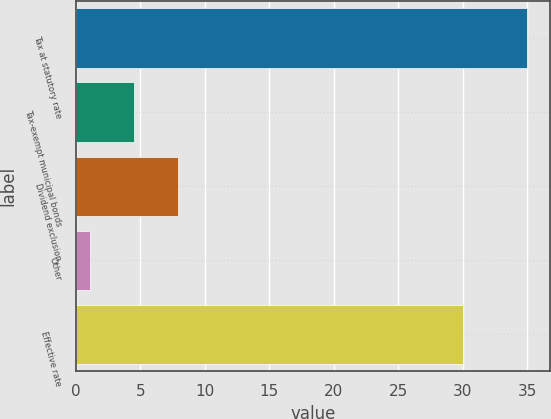Convert chart. <chart><loc_0><loc_0><loc_500><loc_500><bar_chart><fcel>Tax at statutory rate<fcel>Tax-exempt municipal bonds<fcel>Dividend exclusion<fcel>Other<fcel>Effective rate<nl><fcel>35<fcel>4.49<fcel>7.88<fcel>1.1<fcel>30<nl></chart> 